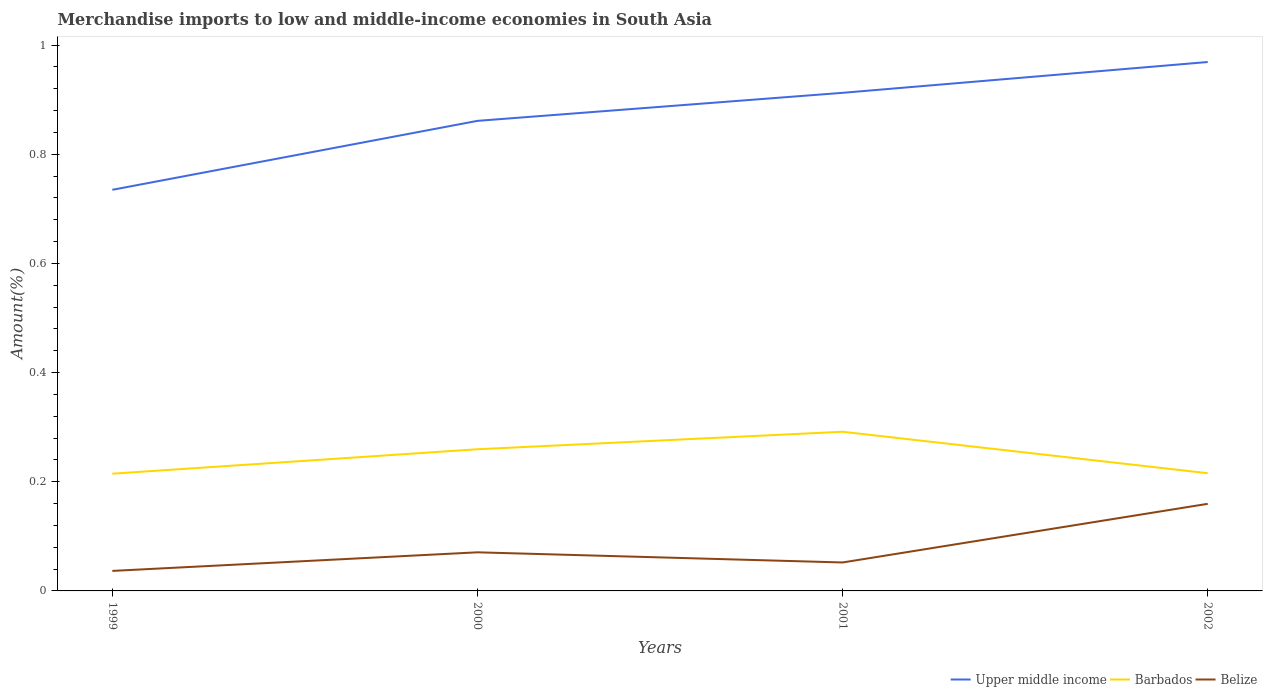Does the line corresponding to Barbados intersect with the line corresponding to Belize?
Give a very brief answer. No. Across all years, what is the maximum percentage of amount earned from merchandise imports in Barbados?
Your answer should be compact. 0.21. What is the total percentage of amount earned from merchandise imports in Upper middle income in the graph?
Your answer should be compact. -0.23. What is the difference between the highest and the second highest percentage of amount earned from merchandise imports in Belize?
Your answer should be compact. 0.12. How many lines are there?
Provide a succinct answer. 3. What is the difference between two consecutive major ticks on the Y-axis?
Your answer should be very brief. 0.2. Are the values on the major ticks of Y-axis written in scientific E-notation?
Offer a terse response. No. Does the graph contain any zero values?
Give a very brief answer. No. Does the graph contain grids?
Give a very brief answer. No. Where does the legend appear in the graph?
Make the answer very short. Bottom right. How many legend labels are there?
Keep it short and to the point. 3. How are the legend labels stacked?
Keep it short and to the point. Horizontal. What is the title of the graph?
Provide a short and direct response. Merchandise imports to low and middle-income economies in South Asia. Does "United Arab Emirates" appear as one of the legend labels in the graph?
Make the answer very short. No. What is the label or title of the X-axis?
Keep it short and to the point. Years. What is the label or title of the Y-axis?
Your answer should be very brief. Amount(%). What is the Amount(%) in Upper middle income in 1999?
Give a very brief answer. 0.73. What is the Amount(%) in Barbados in 1999?
Provide a succinct answer. 0.21. What is the Amount(%) in Belize in 1999?
Ensure brevity in your answer.  0.04. What is the Amount(%) in Upper middle income in 2000?
Make the answer very short. 0.86. What is the Amount(%) in Barbados in 2000?
Provide a short and direct response. 0.26. What is the Amount(%) of Belize in 2000?
Your answer should be very brief. 0.07. What is the Amount(%) in Upper middle income in 2001?
Offer a terse response. 0.91. What is the Amount(%) of Barbados in 2001?
Make the answer very short. 0.29. What is the Amount(%) of Belize in 2001?
Give a very brief answer. 0.05. What is the Amount(%) in Upper middle income in 2002?
Your response must be concise. 0.97. What is the Amount(%) in Barbados in 2002?
Make the answer very short. 0.22. What is the Amount(%) in Belize in 2002?
Your answer should be very brief. 0.16. Across all years, what is the maximum Amount(%) in Upper middle income?
Make the answer very short. 0.97. Across all years, what is the maximum Amount(%) of Barbados?
Offer a very short reply. 0.29. Across all years, what is the maximum Amount(%) in Belize?
Give a very brief answer. 0.16. Across all years, what is the minimum Amount(%) of Upper middle income?
Your response must be concise. 0.73. Across all years, what is the minimum Amount(%) in Barbados?
Your response must be concise. 0.21. Across all years, what is the minimum Amount(%) of Belize?
Your response must be concise. 0.04. What is the total Amount(%) in Upper middle income in the graph?
Keep it short and to the point. 3.48. What is the total Amount(%) of Barbados in the graph?
Provide a short and direct response. 0.98. What is the total Amount(%) of Belize in the graph?
Provide a short and direct response. 0.32. What is the difference between the Amount(%) of Upper middle income in 1999 and that in 2000?
Provide a succinct answer. -0.13. What is the difference between the Amount(%) of Barbados in 1999 and that in 2000?
Offer a terse response. -0.04. What is the difference between the Amount(%) of Belize in 1999 and that in 2000?
Offer a terse response. -0.03. What is the difference between the Amount(%) in Upper middle income in 1999 and that in 2001?
Offer a very short reply. -0.18. What is the difference between the Amount(%) of Barbados in 1999 and that in 2001?
Your answer should be very brief. -0.08. What is the difference between the Amount(%) in Belize in 1999 and that in 2001?
Keep it short and to the point. -0.02. What is the difference between the Amount(%) of Upper middle income in 1999 and that in 2002?
Provide a short and direct response. -0.23. What is the difference between the Amount(%) of Barbados in 1999 and that in 2002?
Your answer should be very brief. -0. What is the difference between the Amount(%) in Belize in 1999 and that in 2002?
Ensure brevity in your answer.  -0.12. What is the difference between the Amount(%) in Upper middle income in 2000 and that in 2001?
Provide a short and direct response. -0.05. What is the difference between the Amount(%) of Barbados in 2000 and that in 2001?
Your answer should be compact. -0.03. What is the difference between the Amount(%) of Belize in 2000 and that in 2001?
Offer a very short reply. 0.02. What is the difference between the Amount(%) in Upper middle income in 2000 and that in 2002?
Your answer should be very brief. -0.11. What is the difference between the Amount(%) in Barbados in 2000 and that in 2002?
Your answer should be compact. 0.04. What is the difference between the Amount(%) in Belize in 2000 and that in 2002?
Give a very brief answer. -0.09. What is the difference between the Amount(%) of Upper middle income in 2001 and that in 2002?
Your response must be concise. -0.06. What is the difference between the Amount(%) of Barbados in 2001 and that in 2002?
Make the answer very short. 0.08. What is the difference between the Amount(%) in Belize in 2001 and that in 2002?
Your response must be concise. -0.11. What is the difference between the Amount(%) of Upper middle income in 1999 and the Amount(%) of Barbados in 2000?
Give a very brief answer. 0.48. What is the difference between the Amount(%) of Upper middle income in 1999 and the Amount(%) of Belize in 2000?
Offer a terse response. 0.66. What is the difference between the Amount(%) in Barbados in 1999 and the Amount(%) in Belize in 2000?
Make the answer very short. 0.14. What is the difference between the Amount(%) in Upper middle income in 1999 and the Amount(%) in Barbados in 2001?
Your answer should be compact. 0.44. What is the difference between the Amount(%) in Upper middle income in 1999 and the Amount(%) in Belize in 2001?
Provide a short and direct response. 0.68. What is the difference between the Amount(%) of Barbados in 1999 and the Amount(%) of Belize in 2001?
Give a very brief answer. 0.16. What is the difference between the Amount(%) in Upper middle income in 1999 and the Amount(%) in Barbados in 2002?
Offer a very short reply. 0.52. What is the difference between the Amount(%) in Upper middle income in 1999 and the Amount(%) in Belize in 2002?
Your answer should be very brief. 0.58. What is the difference between the Amount(%) of Barbados in 1999 and the Amount(%) of Belize in 2002?
Make the answer very short. 0.06. What is the difference between the Amount(%) of Upper middle income in 2000 and the Amount(%) of Barbados in 2001?
Your answer should be very brief. 0.57. What is the difference between the Amount(%) in Upper middle income in 2000 and the Amount(%) in Belize in 2001?
Your answer should be compact. 0.81. What is the difference between the Amount(%) of Barbados in 2000 and the Amount(%) of Belize in 2001?
Provide a succinct answer. 0.21. What is the difference between the Amount(%) in Upper middle income in 2000 and the Amount(%) in Barbados in 2002?
Offer a terse response. 0.65. What is the difference between the Amount(%) of Upper middle income in 2000 and the Amount(%) of Belize in 2002?
Ensure brevity in your answer.  0.7. What is the difference between the Amount(%) of Barbados in 2000 and the Amount(%) of Belize in 2002?
Keep it short and to the point. 0.1. What is the difference between the Amount(%) in Upper middle income in 2001 and the Amount(%) in Barbados in 2002?
Your response must be concise. 0.7. What is the difference between the Amount(%) of Upper middle income in 2001 and the Amount(%) of Belize in 2002?
Provide a succinct answer. 0.75. What is the difference between the Amount(%) in Barbados in 2001 and the Amount(%) in Belize in 2002?
Offer a terse response. 0.13. What is the average Amount(%) in Upper middle income per year?
Provide a short and direct response. 0.87. What is the average Amount(%) of Barbados per year?
Keep it short and to the point. 0.25. What is the average Amount(%) of Belize per year?
Offer a very short reply. 0.08. In the year 1999, what is the difference between the Amount(%) in Upper middle income and Amount(%) in Barbados?
Your answer should be compact. 0.52. In the year 1999, what is the difference between the Amount(%) in Upper middle income and Amount(%) in Belize?
Provide a succinct answer. 0.7. In the year 1999, what is the difference between the Amount(%) in Barbados and Amount(%) in Belize?
Keep it short and to the point. 0.18. In the year 2000, what is the difference between the Amount(%) in Upper middle income and Amount(%) in Barbados?
Your answer should be very brief. 0.6. In the year 2000, what is the difference between the Amount(%) of Upper middle income and Amount(%) of Belize?
Make the answer very short. 0.79. In the year 2000, what is the difference between the Amount(%) in Barbados and Amount(%) in Belize?
Offer a very short reply. 0.19. In the year 2001, what is the difference between the Amount(%) of Upper middle income and Amount(%) of Barbados?
Keep it short and to the point. 0.62. In the year 2001, what is the difference between the Amount(%) in Upper middle income and Amount(%) in Belize?
Make the answer very short. 0.86. In the year 2001, what is the difference between the Amount(%) of Barbados and Amount(%) of Belize?
Make the answer very short. 0.24. In the year 2002, what is the difference between the Amount(%) in Upper middle income and Amount(%) in Barbados?
Provide a succinct answer. 0.75. In the year 2002, what is the difference between the Amount(%) in Upper middle income and Amount(%) in Belize?
Ensure brevity in your answer.  0.81. In the year 2002, what is the difference between the Amount(%) in Barbados and Amount(%) in Belize?
Your answer should be compact. 0.06. What is the ratio of the Amount(%) of Upper middle income in 1999 to that in 2000?
Ensure brevity in your answer.  0.85. What is the ratio of the Amount(%) in Barbados in 1999 to that in 2000?
Provide a succinct answer. 0.83. What is the ratio of the Amount(%) in Belize in 1999 to that in 2000?
Offer a very short reply. 0.52. What is the ratio of the Amount(%) in Upper middle income in 1999 to that in 2001?
Ensure brevity in your answer.  0.81. What is the ratio of the Amount(%) of Barbados in 1999 to that in 2001?
Ensure brevity in your answer.  0.74. What is the ratio of the Amount(%) of Belize in 1999 to that in 2001?
Keep it short and to the point. 0.7. What is the ratio of the Amount(%) in Upper middle income in 1999 to that in 2002?
Offer a terse response. 0.76. What is the ratio of the Amount(%) in Barbados in 1999 to that in 2002?
Your response must be concise. 1. What is the ratio of the Amount(%) in Belize in 1999 to that in 2002?
Offer a very short reply. 0.23. What is the ratio of the Amount(%) in Upper middle income in 2000 to that in 2001?
Your response must be concise. 0.94. What is the ratio of the Amount(%) of Barbados in 2000 to that in 2001?
Keep it short and to the point. 0.89. What is the ratio of the Amount(%) of Belize in 2000 to that in 2001?
Ensure brevity in your answer.  1.36. What is the ratio of the Amount(%) of Upper middle income in 2000 to that in 2002?
Give a very brief answer. 0.89. What is the ratio of the Amount(%) of Barbados in 2000 to that in 2002?
Provide a short and direct response. 1.2. What is the ratio of the Amount(%) in Belize in 2000 to that in 2002?
Offer a terse response. 0.44. What is the ratio of the Amount(%) in Upper middle income in 2001 to that in 2002?
Your answer should be very brief. 0.94. What is the ratio of the Amount(%) in Barbados in 2001 to that in 2002?
Give a very brief answer. 1.35. What is the ratio of the Amount(%) of Belize in 2001 to that in 2002?
Offer a terse response. 0.33. What is the difference between the highest and the second highest Amount(%) of Upper middle income?
Make the answer very short. 0.06. What is the difference between the highest and the second highest Amount(%) in Barbados?
Give a very brief answer. 0.03. What is the difference between the highest and the second highest Amount(%) in Belize?
Your answer should be very brief. 0.09. What is the difference between the highest and the lowest Amount(%) in Upper middle income?
Provide a short and direct response. 0.23. What is the difference between the highest and the lowest Amount(%) of Barbados?
Keep it short and to the point. 0.08. What is the difference between the highest and the lowest Amount(%) of Belize?
Offer a very short reply. 0.12. 